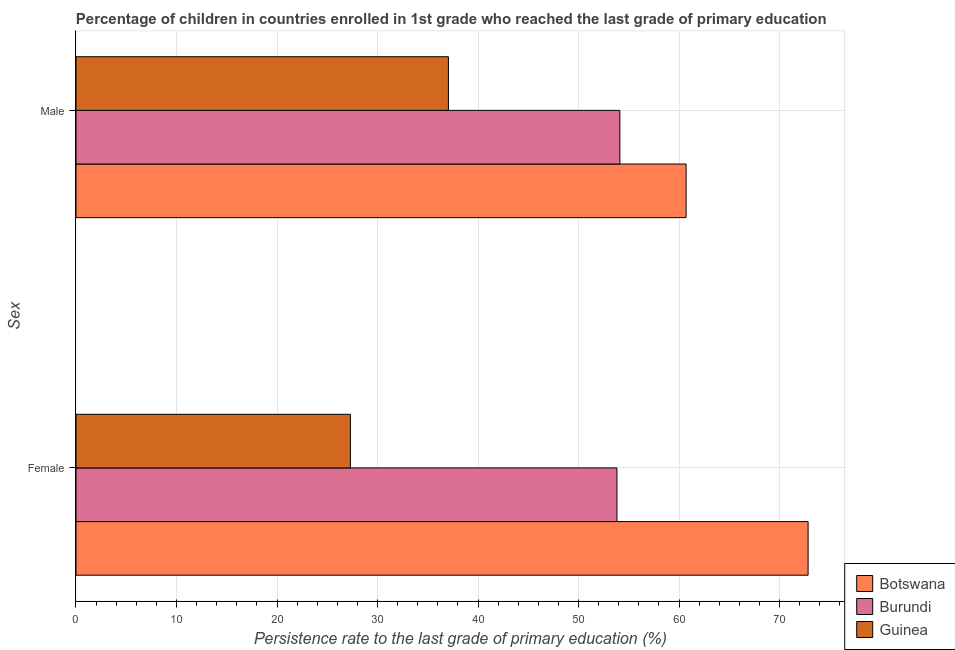Are the number of bars on each tick of the Y-axis equal?
Your answer should be very brief. Yes. What is the persistence rate of female students in Botswana?
Your answer should be compact. 72.84. Across all countries, what is the maximum persistence rate of male students?
Your answer should be very brief. 60.7. Across all countries, what is the minimum persistence rate of female students?
Offer a very short reply. 27.3. In which country was the persistence rate of male students maximum?
Offer a very short reply. Botswana. In which country was the persistence rate of female students minimum?
Your answer should be very brief. Guinea. What is the total persistence rate of female students in the graph?
Offer a very short reply. 153.97. What is the difference between the persistence rate of female students in Botswana and that in Burundi?
Your answer should be very brief. 19.02. What is the difference between the persistence rate of female students in Botswana and the persistence rate of male students in Burundi?
Provide a short and direct response. 18.73. What is the average persistence rate of male students per country?
Provide a succinct answer. 50.62. What is the difference between the persistence rate of female students and persistence rate of male students in Burundi?
Offer a very short reply. -0.29. What is the ratio of the persistence rate of female students in Guinea to that in Burundi?
Your answer should be very brief. 0.51. In how many countries, is the persistence rate of male students greater than the average persistence rate of male students taken over all countries?
Offer a very short reply. 2. What does the 3rd bar from the top in Male represents?
Provide a short and direct response. Botswana. What does the 2nd bar from the bottom in Male represents?
Provide a short and direct response. Burundi. How many bars are there?
Provide a succinct answer. 6. Are all the bars in the graph horizontal?
Keep it short and to the point. Yes. Does the graph contain grids?
Provide a short and direct response. Yes. How many legend labels are there?
Ensure brevity in your answer.  3. How are the legend labels stacked?
Keep it short and to the point. Vertical. What is the title of the graph?
Keep it short and to the point. Percentage of children in countries enrolled in 1st grade who reached the last grade of primary education. What is the label or title of the X-axis?
Offer a very short reply. Persistence rate to the last grade of primary education (%). What is the label or title of the Y-axis?
Provide a succinct answer. Sex. What is the Persistence rate to the last grade of primary education (%) of Botswana in Female?
Your answer should be very brief. 72.84. What is the Persistence rate to the last grade of primary education (%) in Burundi in Female?
Offer a terse response. 53.83. What is the Persistence rate to the last grade of primary education (%) of Guinea in Female?
Ensure brevity in your answer.  27.3. What is the Persistence rate to the last grade of primary education (%) of Botswana in Male?
Give a very brief answer. 60.7. What is the Persistence rate to the last grade of primary education (%) of Burundi in Male?
Your answer should be compact. 54.11. What is the Persistence rate to the last grade of primary education (%) of Guinea in Male?
Provide a succinct answer. 37.06. Across all Sex, what is the maximum Persistence rate to the last grade of primary education (%) of Botswana?
Provide a short and direct response. 72.84. Across all Sex, what is the maximum Persistence rate to the last grade of primary education (%) in Burundi?
Ensure brevity in your answer.  54.11. Across all Sex, what is the maximum Persistence rate to the last grade of primary education (%) in Guinea?
Your answer should be compact. 37.06. Across all Sex, what is the minimum Persistence rate to the last grade of primary education (%) of Botswana?
Make the answer very short. 60.7. Across all Sex, what is the minimum Persistence rate to the last grade of primary education (%) in Burundi?
Make the answer very short. 53.83. Across all Sex, what is the minimum Persistence rate to the last grade of primary education (%) in Guinea?
Provide a succinct answer. 27.3. What is the total Persistence rate to the last grade of primary education (%) of Botswana in the graph?
Ensure brevity in your answer.  133.55. What is the total Persistence rate to the last grade of primary education (%) of Burundi in the graph?
Make the answer very short. 107.94. What is the total Persistence rate to the last grade of primary education (%) of Guinea in the graph?
Your answer should be very brief. 64.36. What is the difference between the Persistence rate to the last grade of primary education (%) of Botswana in Female and that in Male?
Offer a very short reply. 12.14. What is the difference between the Persistence rate to the last grade of primary education (%) of Burundi in Female and that in Male?
Give a very brief answer. -0.29. What is the difference between the Persistence rate to the last grade of primary education (%) in Guinea in Female and that in Male?
Make the answer very short. -9.75. What is the difference between the Persistence rate to the last grade of primary education (%) in Botswana in Female and the Persistence rate to the last grade of primary education (%) in Burundi in Male?
Provide a short and direct response. 18.73. What is the difference between the Persistence rate to the last grade of primary education (%) in Botswana in Female and the Persistence rate to the last grade of primary education (%) in Guinea in Male?
Your answer should be compact. 35.79. What is the difference between the Persistence rate to the last grade of primary education (%) of Burundi in Female and the Persistence rate to the last grade of primary education (%) of Guinea in Male?
Your answer should be very brief. 16.77. What is the average Persistence rate to the last grade of primary education (%) in Botswana per Sex?
Ensure brevity in your answer.  66.77. What is the average Persistence rate to the last grade of primary education (%) of Burundi per Sex?
Your response must be concise. 53.97. What is the average Persistence rate to the last grade of primary education (%) in Guinea per Sex?
Ensure brevity in your answer.  32.18. What is the difference between the Persistence rate to the last grade of primary education (%) of Botswana and Persistence rate to the last grade of primary education (%) of Burundi in Female?
Provide a succinct answer. 19.02. What is the difference between the Persistence rate to the last grade of primary education (%) of Botswana and Persistence rate to the last grade of primary education (%) of Guinea in Female?
Your answer should be compact. 45.54. What is the difference between the Persistence rate to the last grade of primary education (%) of Burundi and Persistence rate to the last grade of primary education (%) of Guinea in Female?
Offer a very short reply. 26.52. What is the difference between the Persistence rate to the last grade of primary education (%) of Botswana and Persistence rate to the last grade of primary education (%) of Burundi in Male?
Provide a short and direct response. 6.59. What is the difference between the Persistence rate to the last grade of primary education (%) of Botswana and Persistence rate to the last grade of primary education (%) of Guinea in Male?
Offer a very short reply. 23.65. What is the difference between the Persistence rate to the last grade of primary education (%) in Burundi and Persistence rate to the last grade of primary education (%) in Guinea in Male?
Provide a short and direct response. 17.06. What is the ratio of the Persistence rate to the last grade of primary education (%) in Burundi in Female to that in Male?
Make the answer very short. 0.99. What is the ratio of the Persistence rate to the last grade of primary education (%) in Guinea in Female to that in Male?
Keep it short and to the point. 0.74. What is the difference between the highest and the second highest Persistence rate to the last grade of primary education (%) in Botswana?
Make the answer very short. 12.14. What is the difference between the highest and the second highest Persistence rate to the last grade of primary education (%) in Burundi?
Your answer should be very brief. 0.29. What is the difference between the highest and the second highest Persistence rate to the last grade of primary education (%) in Guinea?
Provide a short and direct response. 9.75. What is the difference between the highest and the lowest Persistence rate to the last grade of primary education (%) of Botswana?
Provide a short and direct response. 12.14. What is the difference between the highest and the lowest Persistence rate to the last grade of primary education (%) of Burundi?
Provide a short and direct response. 0.29. What is the difference between the highest and the lowest Persistence rate to the last grade of primary education (%) in Guinea?
Provide a short and direct response. 9.75. 